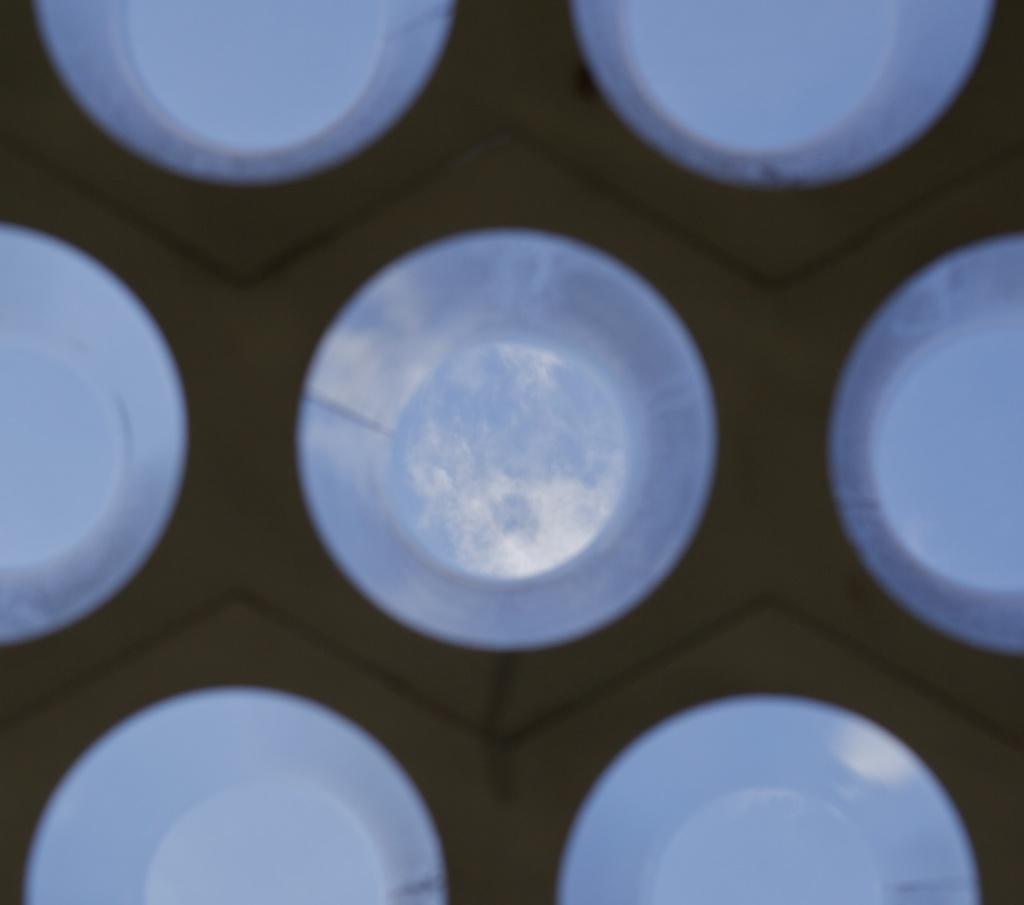Please provide a concise description of this image. In this image I see the brown color surface on which there are white color circles. 